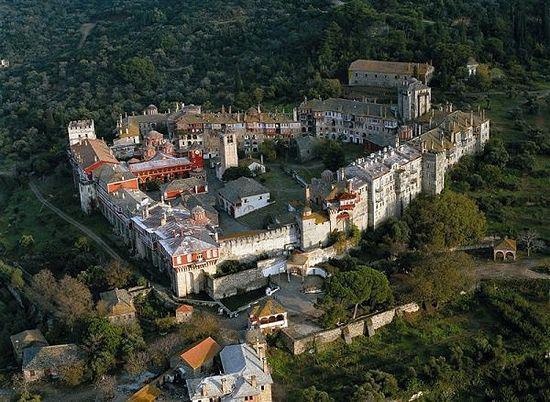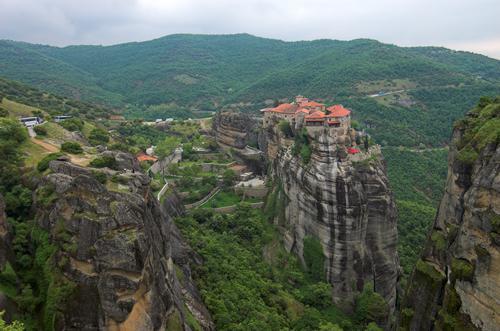The first image is the image on the left, the second image is the image on the right. Considering the images on both sides, is "Cliffs can be seen behind the castle on the left." valid? Answer yes or no. No. The first image is the image on the left, the second image is the image on the right. Given the left and right images, does the statement "Terraced steps with greenery lead up to a series of squarish buildings with neutral-colored roofs in one image." hold true? Answer yes or no. No. 